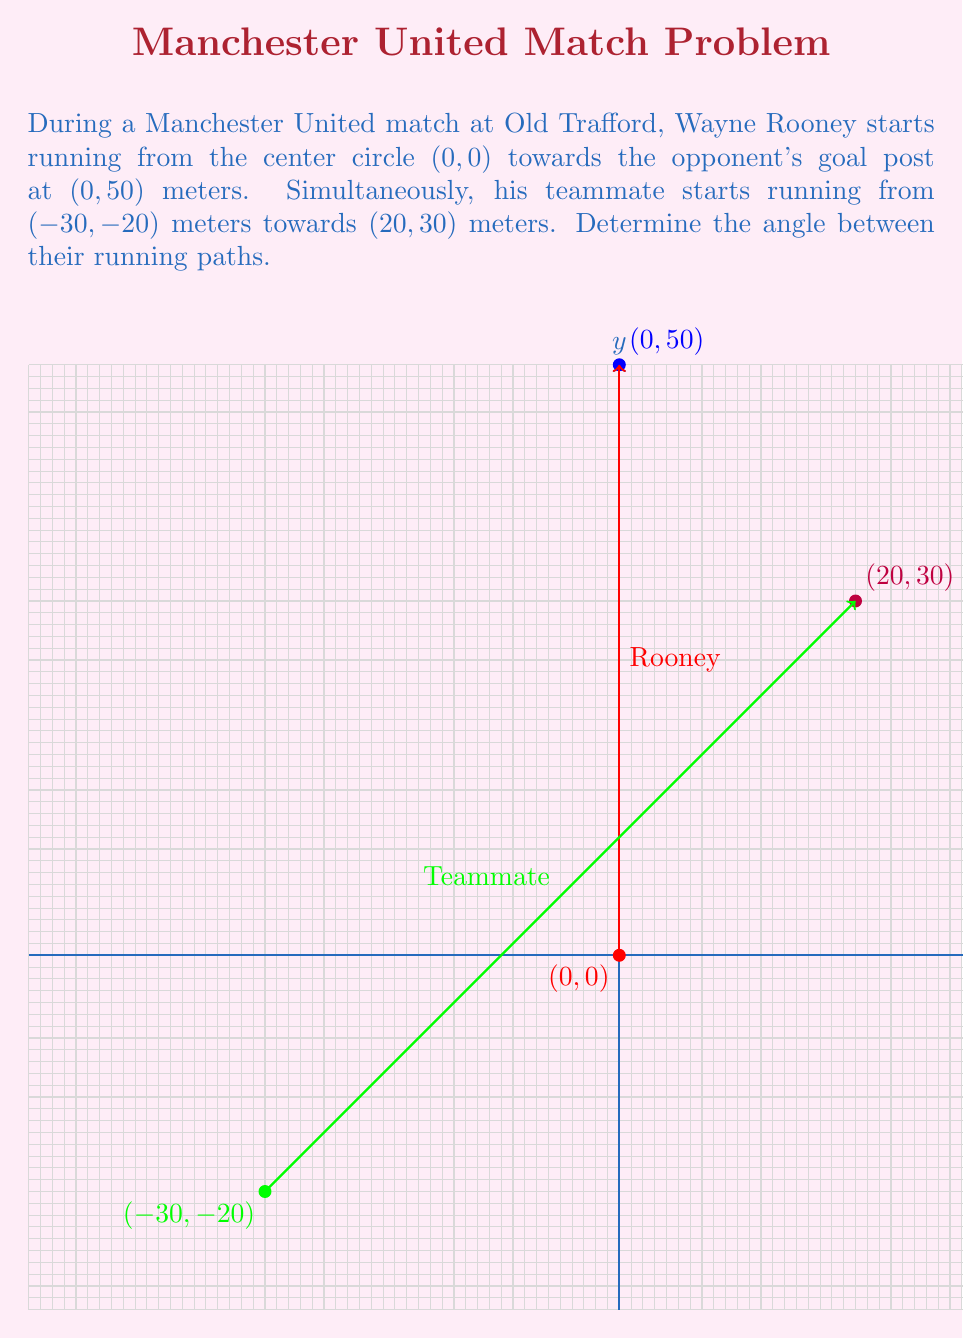Teach me how to tackle this problem. Let's solve this step-by-step:

1) First, we need to find the vectors representing each player's movement:

   Rooney's vector: $\vec{v_1} = (0, 50) - (0, 0) = (0, 50)$
   Teammate's vector: $\vec{v_2} = (20, 30) - (-30, -20) = (50, 50)$

2) To find the angle between these vectors, we can use the dot product formula:

   $\cos \theta = \frac{\vec{v_1} \cdot \vec{v_2}}{|\vec{v_1}| |\vec{v_2}|}$

3) Calculate the dot product $\vec{v_1} \cdot \vec{v_2}$:
   
   $\vec{v_1} \cdot \vec{v_2} = (0 \times 50) + (50 \times 50) = 2500$

4) Calculate the magnitudes of the vectors:

   $|\vec{v_1}| = \sqrt{0^2 + 50^2} = 50$
   $|\vec{v_2}| = \sqrt{50^2 + 50^2} = 50\sqrt{2}$

5) Now, let's substitute these values into the formula:

   $\cos \theta = \frac{2500}{50 \times 50\sqrt{2}} = \frac{2500}{2500\sqrt{2}} = \frac{1}{\sqrt{2}}$

6) To find $\theta$, we need to take the inverse cosine (arccos) of both sides:

   $\theta = \arccos(\frac{1}{\sqrt{2}})$

7) This equals approximately 45 degrees.
Answer: $45^\circ$ 